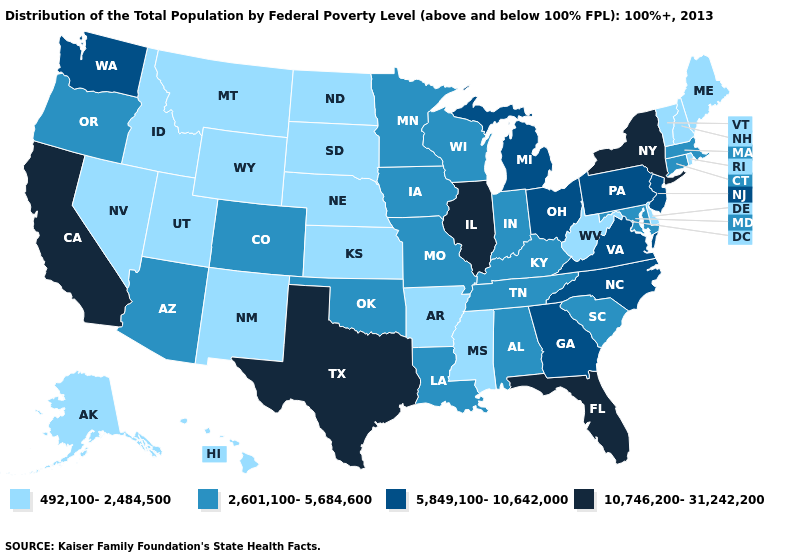Name the states that have a value in the range 2,601,100-5,684,600?
Quick response, please. Alabama, Arizona, Colorado, Connecticut, Indiana, Iowa, Kentucky, Louisiana, Maryland, Massachusetts, Minnesota, Missouri, Oklahoma, Oregon, South Carolina, Tennessee, Wisconsin. What is the value of Arkansas?
Quick response, please. 492,100-2,484,500. What is the highest value in states that border Kansas?
Give a very brief answer. 2,601,100-5,684,600. Does Alabama have the highest value in the USA?
Answer briefly. No. What is the value of Kansas?
Answer briefly. 492,100-2,484,500. Name the states that have a value in the range 2,601,100-5,684,600?
Keep it brief. Alabama, Arizona, Colorado, Connecticut, Indiana, Iowa, Kentucky, Louisiana, Maryland, Massachusetts, Minnesota, Missouri, Oklahoma, Oregon, South Carolina, Tennessee, Wisconsin. What is the value of Iowa?
Quick response, please. 2,601,100-5,684,600. Does Utah have the same value as Montana?
Give a very brief answer. Yes. What is the value of Hawaii?
Quick response, please. 492,100-2,484,500. What is the value of North Carolina?
Write a very short answer. 5,849,100-10,642,000. Name the states that have a value in the range 10,746,200-31,242,200?
Be succinct. California, Florida, Illinois, New York, Texas. Name the states that have a value in the range 2,601,100-5,684,600?
Quick response, please. Alabama, Arizona, Colorado, Connecticut, Indiana, Iowa, Kentucky, Louisiana, Maryland, Massachusetts, Minnesota, Missouri, Oklahoma, Oregon, South Carolina, Tennessee, Wisconsin. Among the states that border Colorado , which have the lowest value?
Be succinct. Kansas, Nebraska, New Mexico, Utah, Wyoming. What is the lowest value in the USA?
Be succinct. 492,100-2,484,500. 